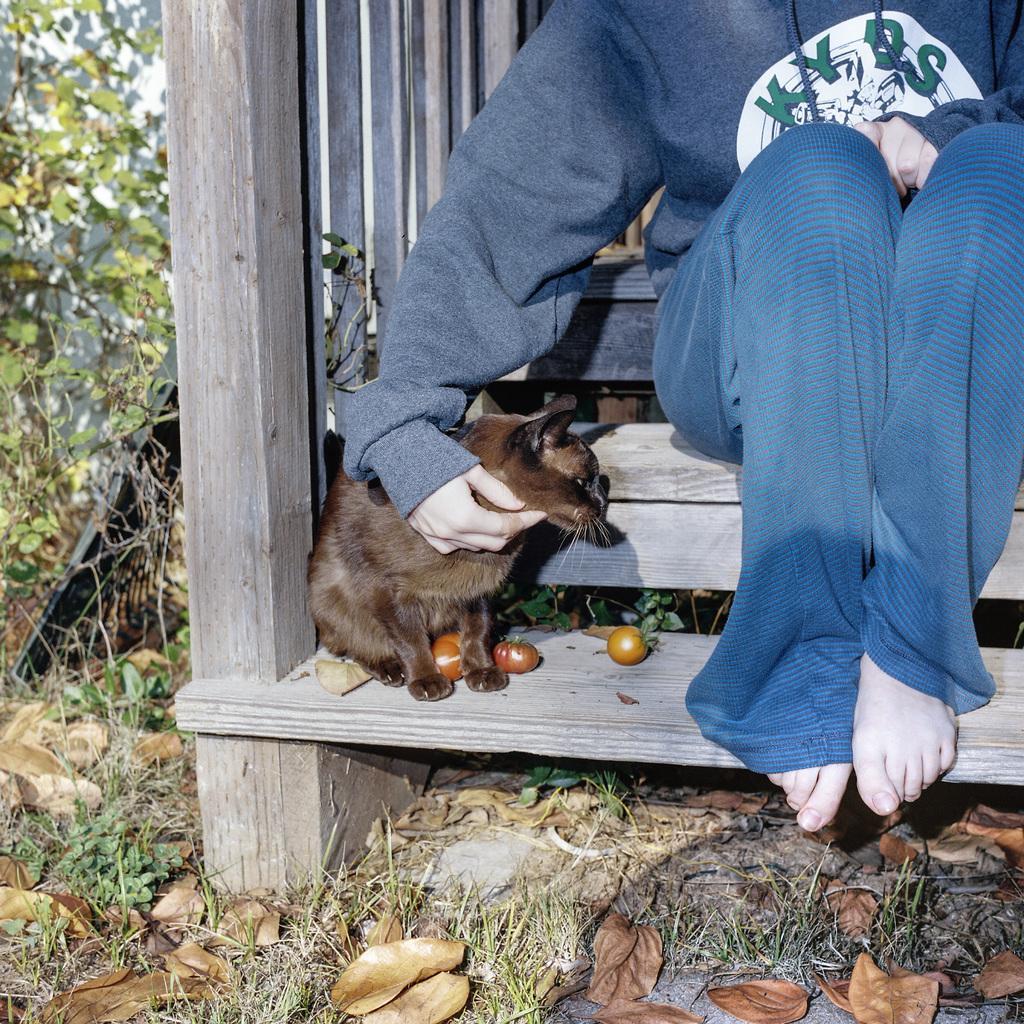Describe this image in one or two sentences. In the foreground, I can see a cat, tomatoes and a person is sitting on a staircase. In the background, I can see grass, creepers and a wall. This picture might be taken in a day. 